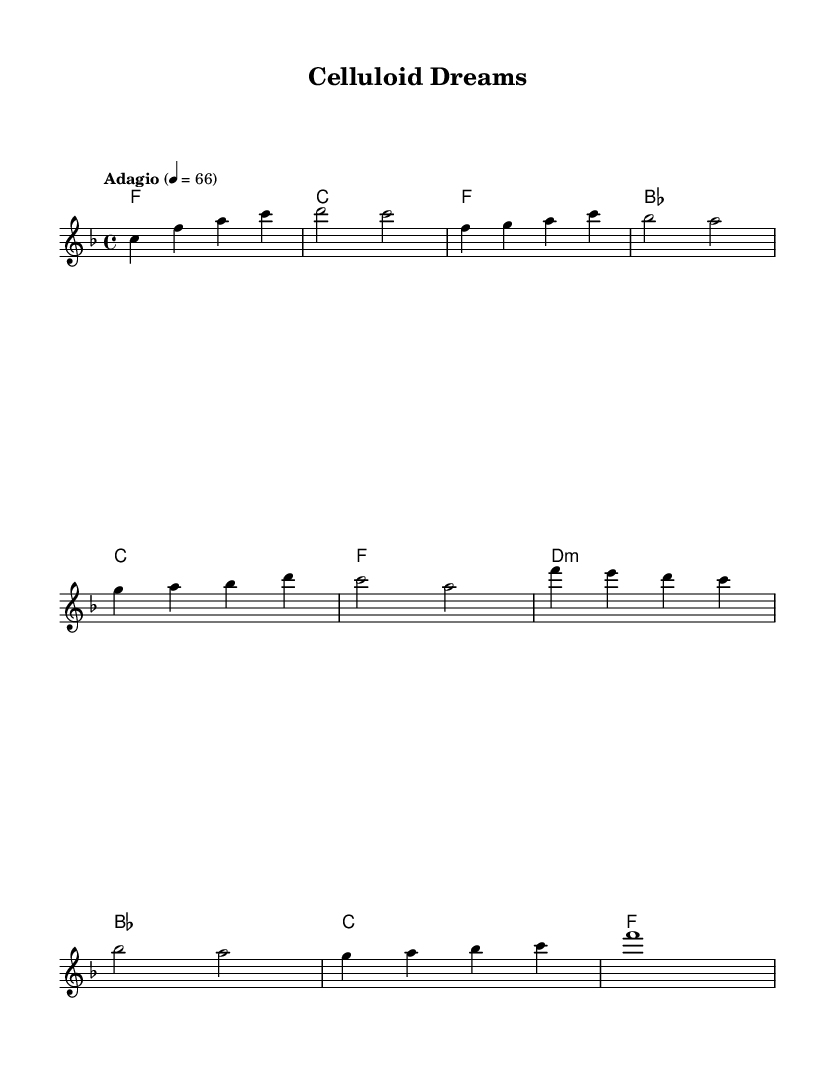What is the key signature of this music? The key signature is indicated in the initial part of the music sheet. Here, it shows one flat, which denotes F major.
Answer: F major What is the time signature of this sheet music? The time signature is found at the beginning of the sheet music. It is represented as 4/4, meaning there are four beats in a measure and a quarter note gets one beat.
Answer: 4/4 What is the tempo marking for the piece? The tempo is specified in the score, described as "Adagio" with an indication of 4 equals 66. This means to play slowly, at a speed of 66 beats per minute.
Answer: Adagio How many measures are in the verse section? The verse section is identified in the sheet music, and by counting the measures, we find there are four measures in this section.
Answer: 4 What chord follows the melody's last note in the chorus? The chorus section shows the last melody note 'c' accompanied by the chord F major, which is indicated in the harmonies.
Answer: F Is there a dynamic marking in this piece? The score presented does not show any explicit dynamic markings such as forte or piano, indicating that dynamics might be interpreted by the performer.
Answer: None 